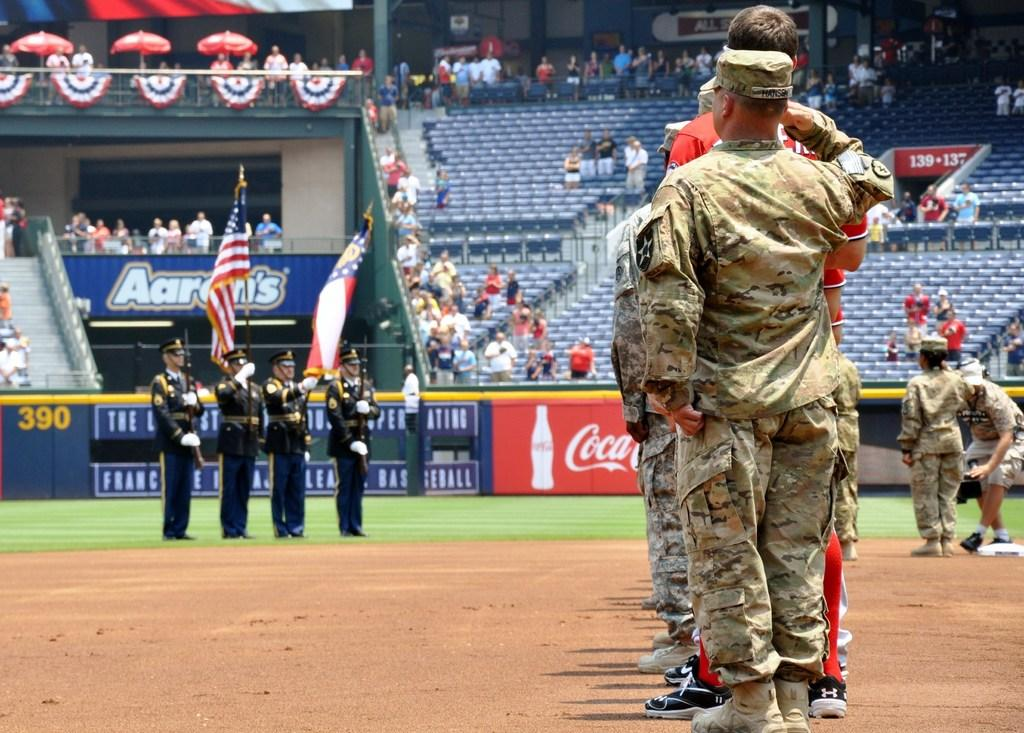<image>
Summarize the visual content of the image. a group of uniformed military standing on a baseball field sponsored by coca-cola 